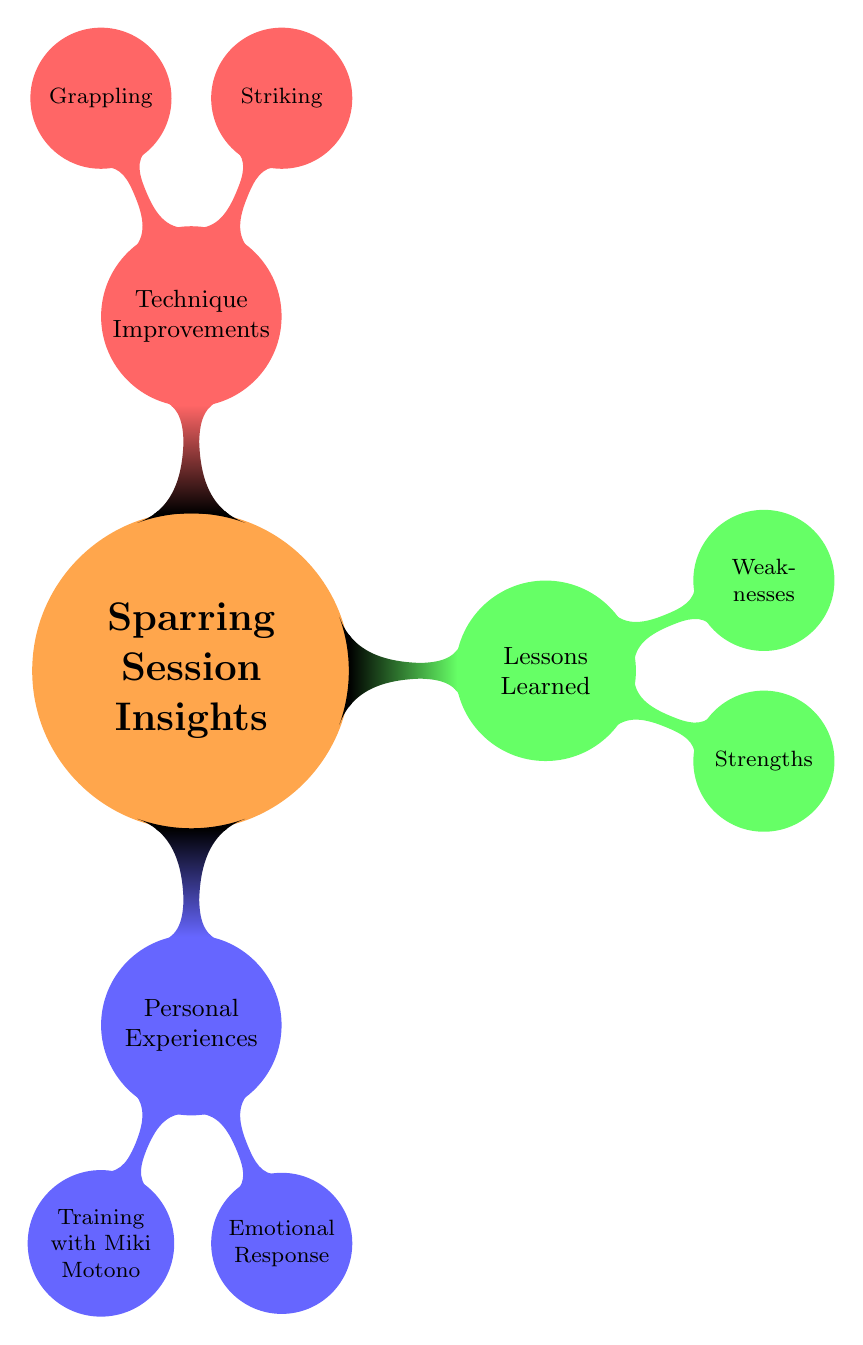What is the color of the node labeled "Lessons Learned"? In the diagram, the node labeled "Lessons Learned" is colored green.
Answer: green How many main branches does the "Sparring Session Insights" node have? The diagram shows three main branches extending from the "Sparring Session Insights" node: Personal Experiences, Lessons Learned, and Technique Improvements.
Answer: 3 What emotional response is noted in the diagram? The emotional response noted in the diagram includes nervousness and increased confidence post-session.
Answer: nervousness, increased confidence What aspect of striking improved during the sparring session? The diagram indicates that the jab-cross combo's speed and power were refined, which emphasizes an improvement in striking.
Answer: jab-cross combo What is one identified weakness in the sparring session? According to the diagram, one identified weakness is the gaps in guard, indicating a need for improvement in defense.
Answer: gaps in guard What kind of technique improvements are listed in the "Technique Improvements" section? The "Technique Improvements" section lists improvements in striking and grappling techniques, highlighting the focus on different skill sets in MMA.
Answer: striking, grappling How did the intensity of training with Miki Motono rate? The diagram describes the intensity of training with Miki Motono as high, signifying a challenging sparring experience.
Answer: high Which specific grappling skill learned counters? The diagram mentions that new counters for takedown defense were learned during the sparring session, indicating a focus on grappling skills.
Answer: takedown defense What was the duration of the sparring session? The duration of the sparring session is noted as three rounds, providing specific timing details.
Answer: 3 Rounds 